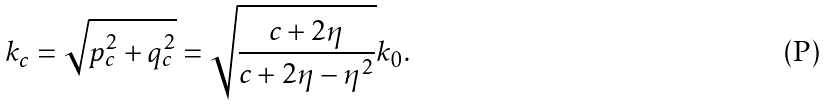<formula> <loc_0><loc_0><loc_500><loc_500>k _ { c } = \sqrt { p _ { c } ^ { 2 } + q _ { c } ^ { 2 } } = \sqrt { \frac { c + 2 \eta } { c + 2 \eta - \eta ^ { 2 } } } k _ { 0 } .</formula> 